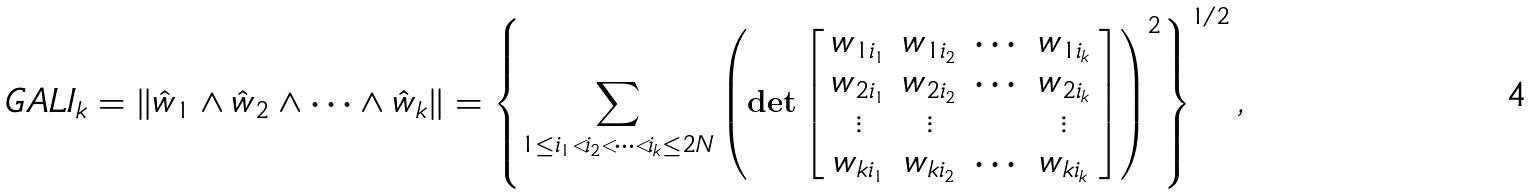Convert formula to latex. <formula><loc_0><loc_0><loc_500><loc_500>G A L I _ { k } = \| \hat { w } _ { 1 } \wedge \hat { w } _ { 2 } \wedge \cdots \wedge \hat { w } _ { k } \| = \left \{ \sum _ { 1 \leq i _ { 1 } < i _ { 2 } < \cdots < i _ { k } \leq 2 N } \left ( \det \left [ \begin{array} { c c c c } w _ { 1 i _ { 1 } } & w _ { 1 i _ { 2 } } & \cdots & w _ { 1 i _ { k } } \\ w _ { 2 i _ { 1 } } & w _ { 2 i _ { 2 } } & \cdots & w _ { 2 i _ { k } } \\ \vdots & \vdots & & \vdots \\ w _ { k i _ { 1 } } & w _ { k i _ { 2 } } & \cdots & w _ { k i _ { k } } \end{array} \right ] \right ) ^ { 2 } \right \} ^ { 1 / 2 } ,</formula> 